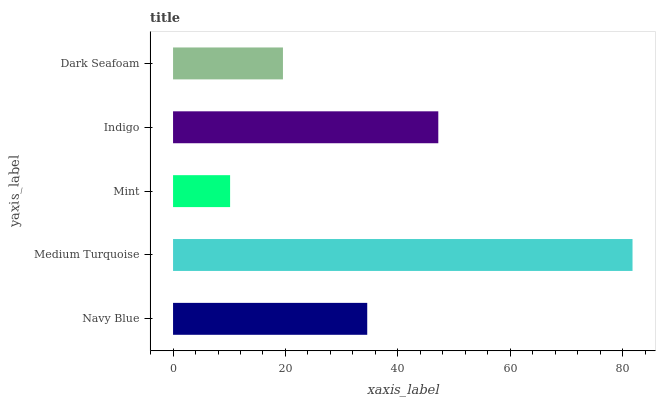Is Mint the minimum?
Answer yes or no. Yes. Is Medium Turquoise the maximum?
Answer yes or no. Yes. Is Medium Turquoise the minimum?
Answer yes or no. No. Is Mint the maximum?
Answer yes or no. No. Is Medium Turquoise greater than Mint?
Answer yes or no. Yes. Is Mint less than Medium Turquoise?
Answer yes or no. Yes. Is Mint greater than Medium Turquoise?
Answer yes or no. No. Is Medium Turquoise less than Mint?
Answer yes or no. No. Is Navy Blue the high median?
Answer yes or no. Yes. Is Navy Blue the low median?
Answer yes or no. Yes. Is Dark Seafoam the high median?
Answer yes or no. No. Is Medium Turquoise the low median?
Answer yes or no. No. 